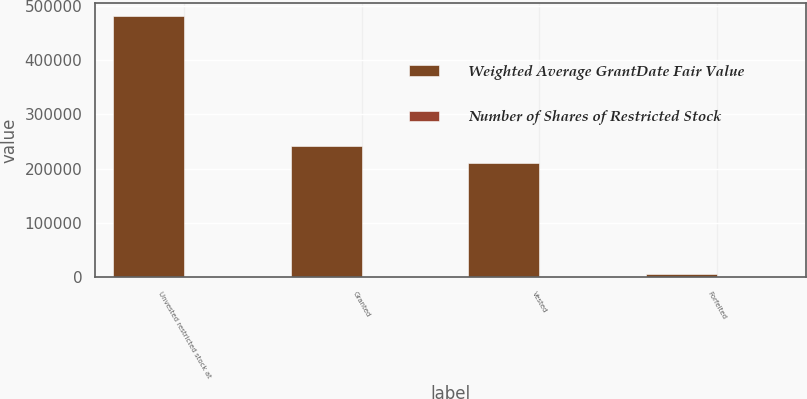<chart> <loc_0><loc_0><loc_500><loc_500><stacked_bar_chart><ecel><fcel>Unvested restricted stock at<fcel>Granted<fcel>Vested<fcel>Forfeited<nl><fcel>Weighted Average GrantDate Fair Value<fcel>480595<fcel>241681<fcel>211235<fcel>6421<nl><fcel>Number of Shares of Restricted Stock<fcel>63.64<fcel>64.1<fcel>48.14<fcel>64.5<nl></chart> 